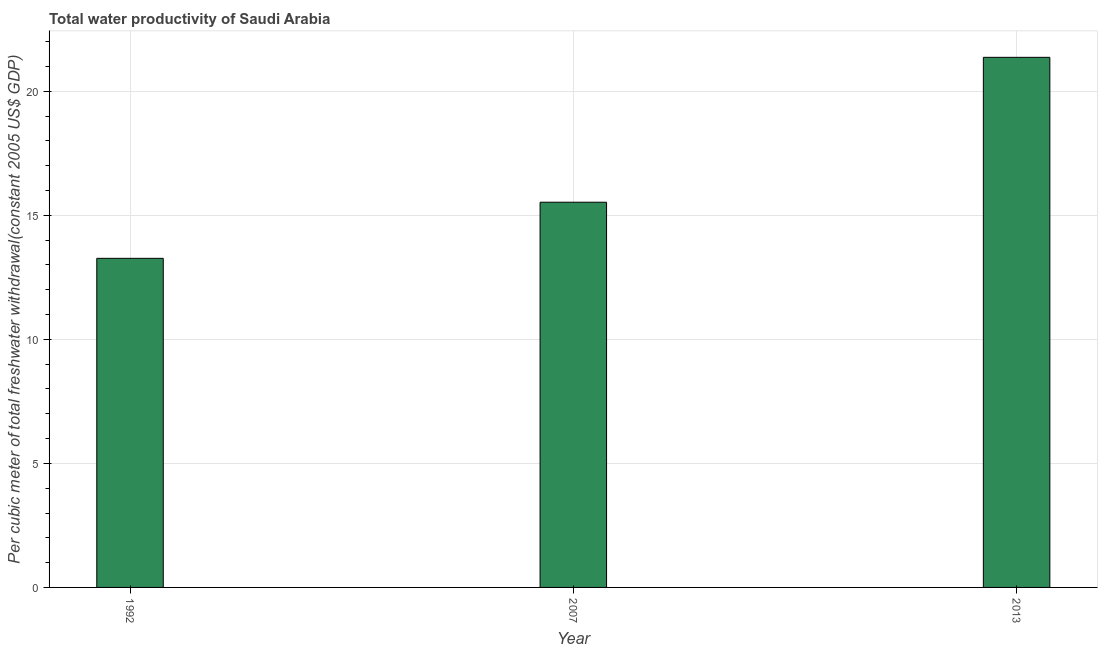Does the graph contain any zero values?
Keep it short and to the point. No. What is the title of the graph?
Give a very brief answer. Total water productivity of Saudi Arabia. What is the label or title of the Y-axis?
Ensure brevity in your answer.  Per cubic meter of total freshwater withdrawal(constant 2005 US$ GDP). What is the total water productivity in 1992?
Your response must be concise. 13.27. Across all years, what is the maximum total water productivity?
Provide a succinct answer. 21.37. Across all years, what is the minimum total water productivity?
Offer a very short reply. 13.27. In which year was the total water productivity maximum?
Give a very brief answer. 2013. In which year was the total water productivity minimum?
Provide a succinct answer. 1992. What is the sum of the total water productivity?
Make the answer very short. 50.16. What is the difference between the total water productivity in 2007 and 2013?
Offer a very short reply. -5.84. What is the average total water productivity per year?
Your answer should be very brief. 16.72. What is the median total water productivity?
Make the answer very short. 15.53. In how many years, is the total water productivity greater than 17 US$?
Give a very brief answer. 1. What is the ratio of the total water productivity in 1992 to that in 2007?
Make the answer very short. 0.85. Is the total water productivity in 2007 less than that in 2013?
Your answer should be very brief. Yes. What is the difference between the highest and the second highest total water productivity?
Your answer should be compact. 5.84. What is the difference between the highest and the lowest total water productivity?
Provide a succinct answer. 8.1. How many bars are there?
Make the answer very short. 3. What is the Per cubic meter of total freshwater withdrawal(constant 2005 US$ GDP) of 1992?
Provide a short and direct response. 13.27. What is the Per cubic meter of total freshwater withdrawal(constant 2005 US$ GDP) in 2007?
Give a very brief answer. 15.53. What is the Per cubic meter of total freshwater withdrawal(constant 2005 US$ GDP) in 2013?
Provide a short and direct response. 21.37. What is the difference between the Per cubic meter of total freshwater withdrawal(constant 2005 US$ GDP) in 1992 and 2007?
Provide a succinct answer. -2.26. What is the difference between the Per cubic meter of total freshwater withdrawal(constant 2005 US$ GDP) in 1992 and 2013?
Offer a terse response. -8.1. What is the difference between the Per cubic meter of total freshwater withdrawal(constant 2005 US$ GDP) in 2007 and 2013?
Provide a succinct answer. -5.84. What is the ratio of the Per cubic meter of total freshwater withdrawal(constant 2005 US$ GDP) in 1992 to that in 2007?
Keep it short and to the point. 0.85. What is the ratio of the Per cubic meter of total freshwater withdrawal(constant 2005 US$ GDP) in 1992 to that in 2013?
Provide a succinct answer. 0.62. What is the ratio of the Per cubic meter of total freshwater withdrawal(constant 2005 US$ GDP) in 2007 to that in 2013?
Give a very brief answer. 0.73. 